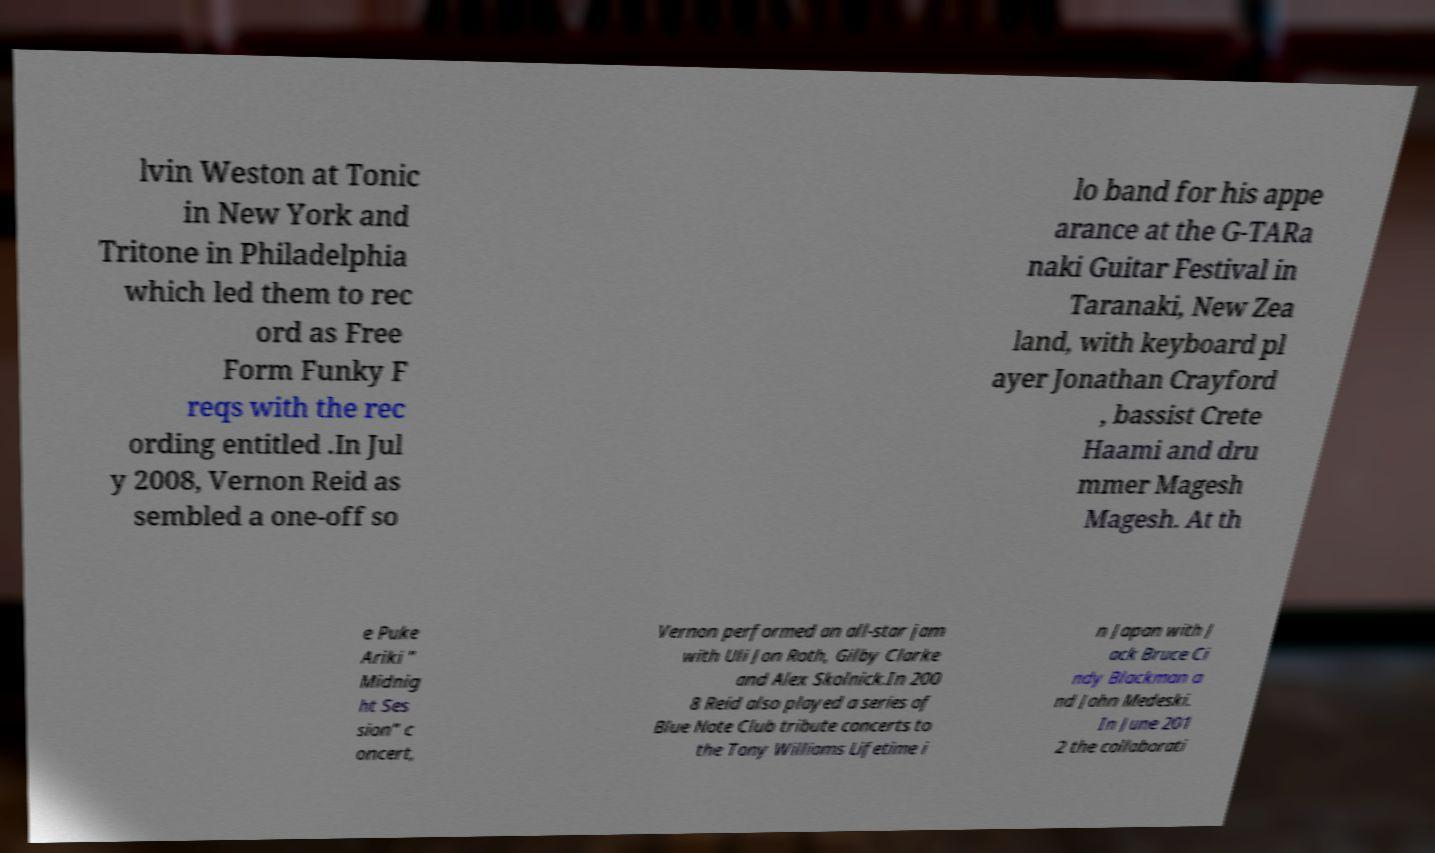For documentation purposes, I need the text within this image transcribed. Could you provide that? lvin Weston at Tonic in New York and Tritone in Philadelphia which led them to rec ord as Free Form Funky F reqs with the rec ording entitled .In Jul y 2008, Vernon Reid as sembled a one-off so lo band for his appe arance at the G-TARa naki Guitar Festival in Taranaki, New Zea land, with keyboard pl ayer Jonathan Crayford , bassist Crete Haami and dru mmer Magesh Magesh. At th e Puke Ariki " Midnig ht Ses sion" c oncert, Vernon performed an all-star jam with Uli Jon Roth, Gilby Clarke and Alex Skolnick.In 200 8 Reid also played a series of Blue Note Club tribute concerts to the Tony Williams Lifetime i n Japan with J ack Bruce Ci ndy Blackman a nd John Medeski. In June 201 2 the collaborati 